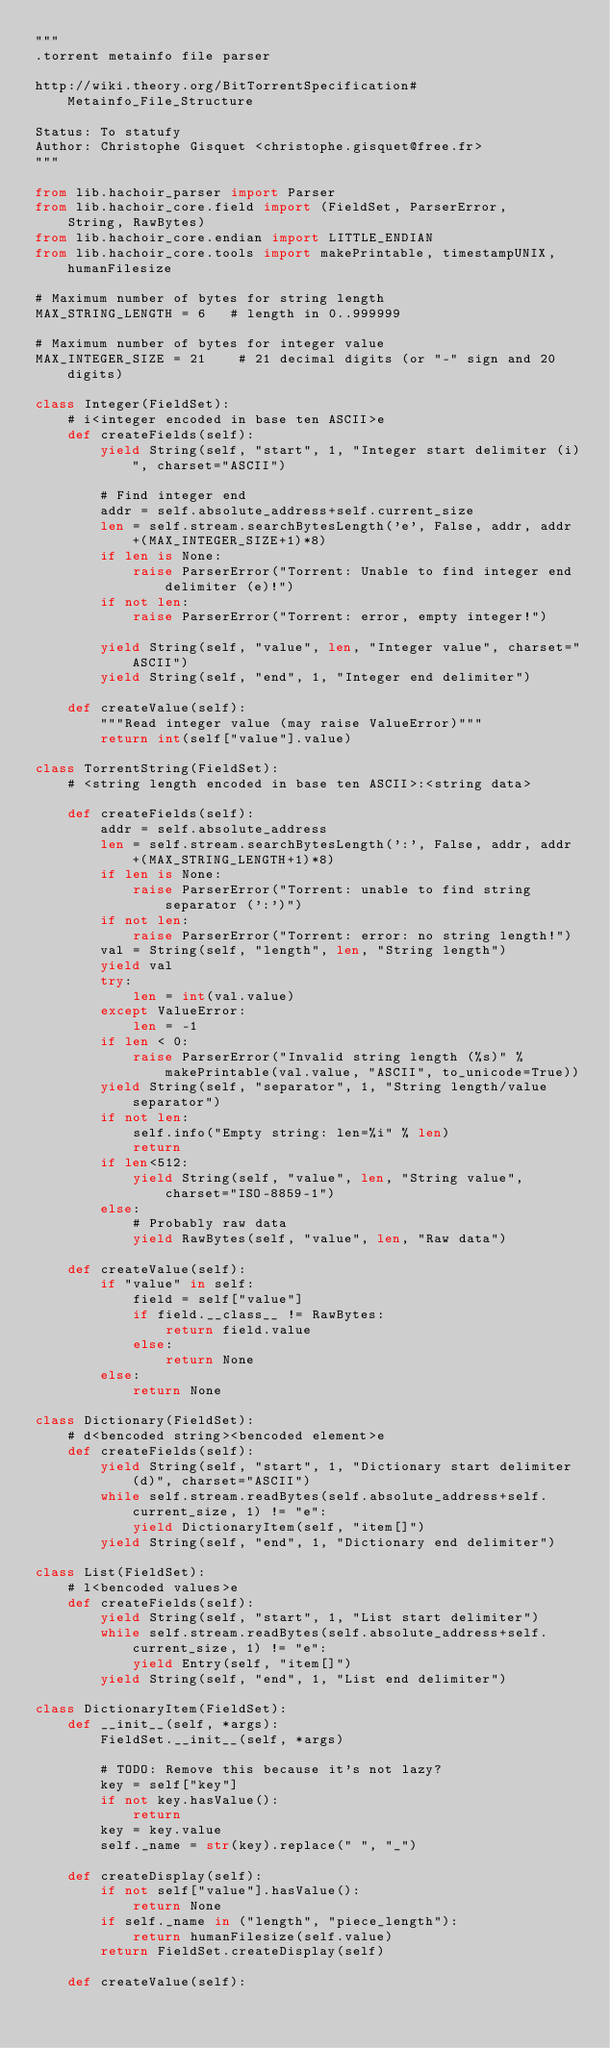<code> <loc_0><loc_0><loc_500><loc_500><_Python_>"""
.torrent metainfo file parser

http://wiki.theory.org/BitTorrentSpecification#Metainfo_File_Structure

Status: To statufy
Author: Christophe Gisquet <christophe.gisquet@free.fr>
"""

from lib.hachoir_parser import Parser
from lib.hachoir_core.field import (FieldSet, ParserError,
    String, RawBytes)
from lib.hachoir_core.endian import LITTLE_ENDIAN
from lib.hachoir_core.tools import makePrintable, timestampUNIX, humanFilesize

# Maximum number of bytes for string length
MAX_STRING_LENGTH = 6   # length in 0..999999

# Maximum number of bytes for integer value
MAX_INTEGER_SIZE = 21    # 21 decimal digits (or "-" sign and 20 digits)

class Integer(FieldSet):
    # i<integer encoded in base ten ASCII>e
    def createFields(self):
        yield String(self, "start", 1, "Integer start delimiter (i)", charset="ASCII")

        # Find integer end
        addr = self.absolute_address+self.current_size
        len = self.stream.searchBytesLength('e', False, addr, addr+(MAX_INTEGER_SIZE+1)*8)
        if len is None:
            raise ParserError("Torrent: Unable to find integer end delimiter (e)!")
        if not len:
            raise ParserError("Torrent: error, empty integer!")

        yield String(self, "value", len, "Integer value", charset="ASCII")
        yield String(self, "end", 1, "Integer end delimiter")

    def createValue(self):
        """Read integer value (may raise ValueError)"""
        return int(self["value"].value)

class TorrentString(FieldSet):
    # <string length encoded in base ten ASCII>:<string data>

    def createFields(self):
        addr = self.absolute_address
        len = self.stream.searchBytesLength(':', False, addr, addr+(MAX_STRING_LENGTH+1)*8)
        if len is None:
            raise ParserError("Torrent: unable to find string separator (':')")
        if not len:
            raise ParserError("Torrent: error: no string length!")
        val = String(self, "length", len, "String length")
        yield val
        try:
            len = int(val.value)
        except ValueError:
            len = -1
        if len < 0:
            raise ParserError("Invalid string length (%s)" % makePrintable(val.value, "ASCII", to_unicode=True))
        yield String(self, "separator", 1, "String length/value separator")
        if not len:
            self.info("Empty string: len=%i" % len)
            return
        if len<512:
            yield String(self, "value", len, "String value", charset="ISO-8859-1")
        else:
            # Probably raw data
            yield RawBytes(self, "value", len, "Raw data")

    def createValue(self):
        if "value" in self:
            field = self["value"]
            if field.__class__ != RawBytes:
                return field.value
            else:
                return None
        else:
            return None

class Dictionary(FieldSet):
    # d<bencoded string><bencoded element>e
    def createFields(self):
        yield String(self, "start", 1, "Dictionary start delimiter (d)", charset="ASCII")
        while self.stream.readBytes(self.absolute_address+self.current_size, 1) != "e":
            yield DictionaryItem(self, "item[]")
        yield String(self, "end", 1, "Dictionary end delimiter")

class List(FieldSet):
    # l<bencoded values>e
    def createFields(self):
        yield String(self, "start", 1, "List start delimiter")
        while self.stream.readBytes(self.absolute_address+self.current_size, 1) != "e":
            yield Entry(self, "item[]")
        yield String(self, "end", 1, "List end delimiter")

class DictionaryItem(FieldSet):
    def __init__(self, *args):
        FieldSet.__init__(self, *args)

        # TODO: Remove this because it's not lazy?
        key = self["key"]
        if not key.hasValue():
            return
        key = key.value
        self._name = str(key).replace(" ", "_")

    def createDisplay(self):
        if not self["value"].hasValue():
            return None
        if self._name in ("length", "piece_length"):
            return humanFilesize(self.value)
        return FieldSet.createDisplay(self)

    def createValue(self):</code> 